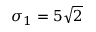Convert formula to latex. <formula><loc_0><loc_0><loc_500><loc_500>\sigma _ { 1 } = 5 \sqrt { 2 }</formula> 